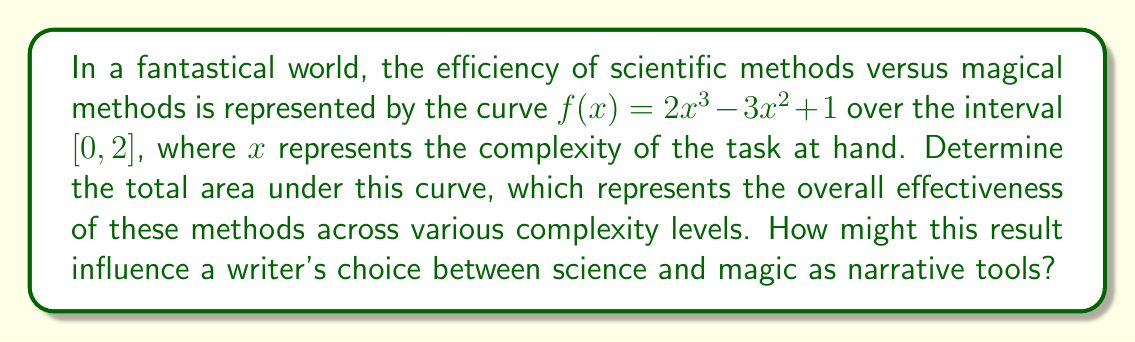Could you help me with this problem? To find the area under the curve, we need to integrate the function $f(x) = 2x^3 - 3x^2 + 1$ over the interval $[0, 2]$. Let's proceed step by step:

1) We use the definite integral:

   $$\int_0^2 (2x^3 - 3x^2 + 1) dx$$

2) Integrate each term:
   
   $$\left[\frac{1}{2}x^4 - x^3 + x\right]_0^2$$

3) Evaluate at the upper and lower bounds:

   $$\left(\frac{1}{2}(2^4) - (2^3) + 2\right) - \left(\frac{1}{2}(0^4) - (0^3) + 0\right)$$

4) Simplify:

   $$(8 - 8 + 2) - (0 - 0 + 0) = 2 - 0 = 2$$

The area under the curve is 2 units squared. This result suggests that over the given complexity range, the overall effectiveness of scientific and magical methods is balanced. A writer could interpret this as both science and magic having equal narrative potential, with their relative strengths varying depending on the complexity of the situation (as represented by different points on the curve).
Answer: 2 square units 